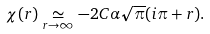<formula> <loc_0><loc_0><loc_500><loc_500>\chi ( r ) \underset { r \rightarrow \infty } { \simeq } - 2 C \alpha \sqrt { \pi } ( i \pi + r ) .</formula> 